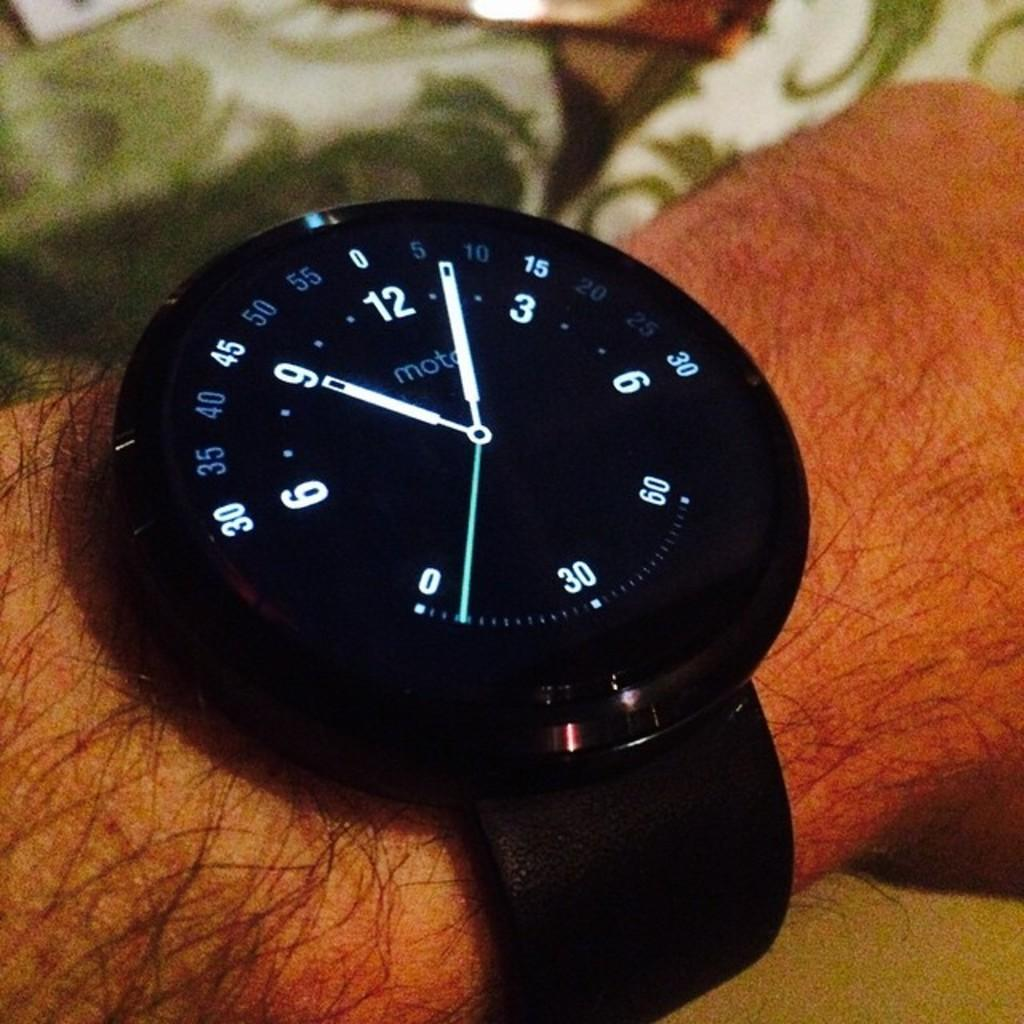<image>
Offer a succinct explanation of the picture presented. a Moto black analog wrist watch on a hairy arm 